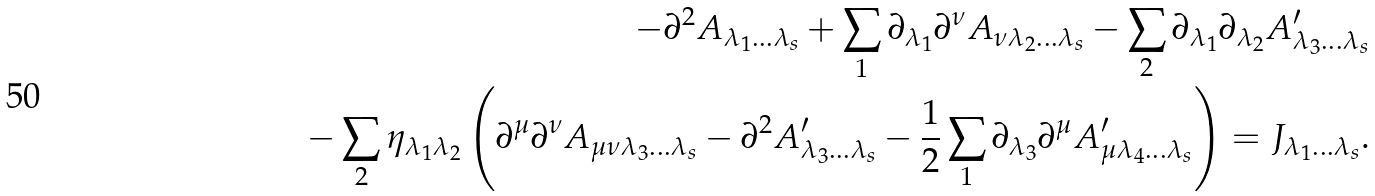<formula> <loc_0><loc_0><loc_500><loc_500>- \partial ^ { 2 } A _ { \lambda _ { 1 } \dots \lambda _ { s } } + \sum _ { 1 } \partial _ { \lambda _ { 1 } } \partial ^ { \nu } A _ { \nu \lambda _ { 2 } \dots \lambda _ { s } } - \sum _ { 2 } \partial _ { \lambda _ { 1 } } \partial _ { \lambda _ { 2 } } A ^ { \prime } _ { \lambda _ { 3 } \dots \lambda _ { s } } \\ \quad - \sum _ { 2 } \eta _ { \lambda _ { 1 } \lambda _ { 2 } } \left ( \partial ^ { \mu } \partial ^ { \nu } A _ { \mu \nu \lambda _ { 3 } \dots \lambda _ { s } } - \partial ^ { 2 } A ^ { \prime } _ { \lambda _ { 3 } \dots \lambda _ { s } } - \frac { 1 } { 2 } \sum _ { 1 } \partial _ { \lambda _ { 3 } } \partial ^ { \mu } A ^ { \prime } _ { \mu \lambda _ { 4 } \dots \lambda _ { s } } \right ) = J _ { \lambda _ { 1 } \dots \lambda _ { s } } .</formula> 